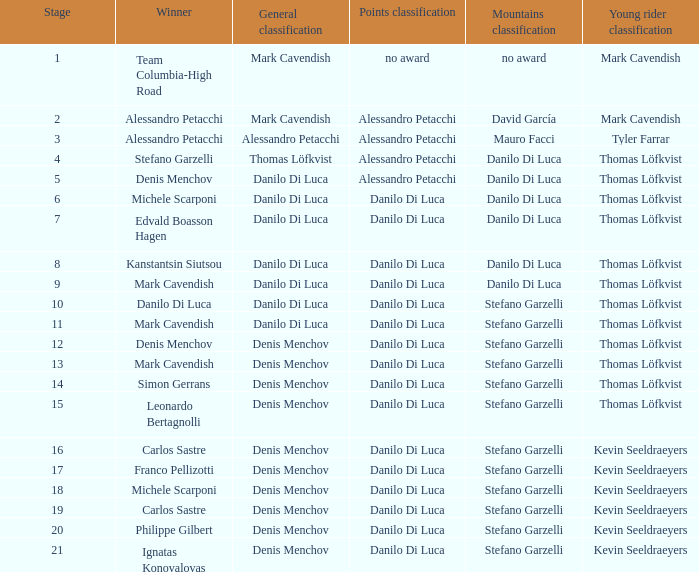When 19 is the stage who is the points classification? Danilo Di Luca. 